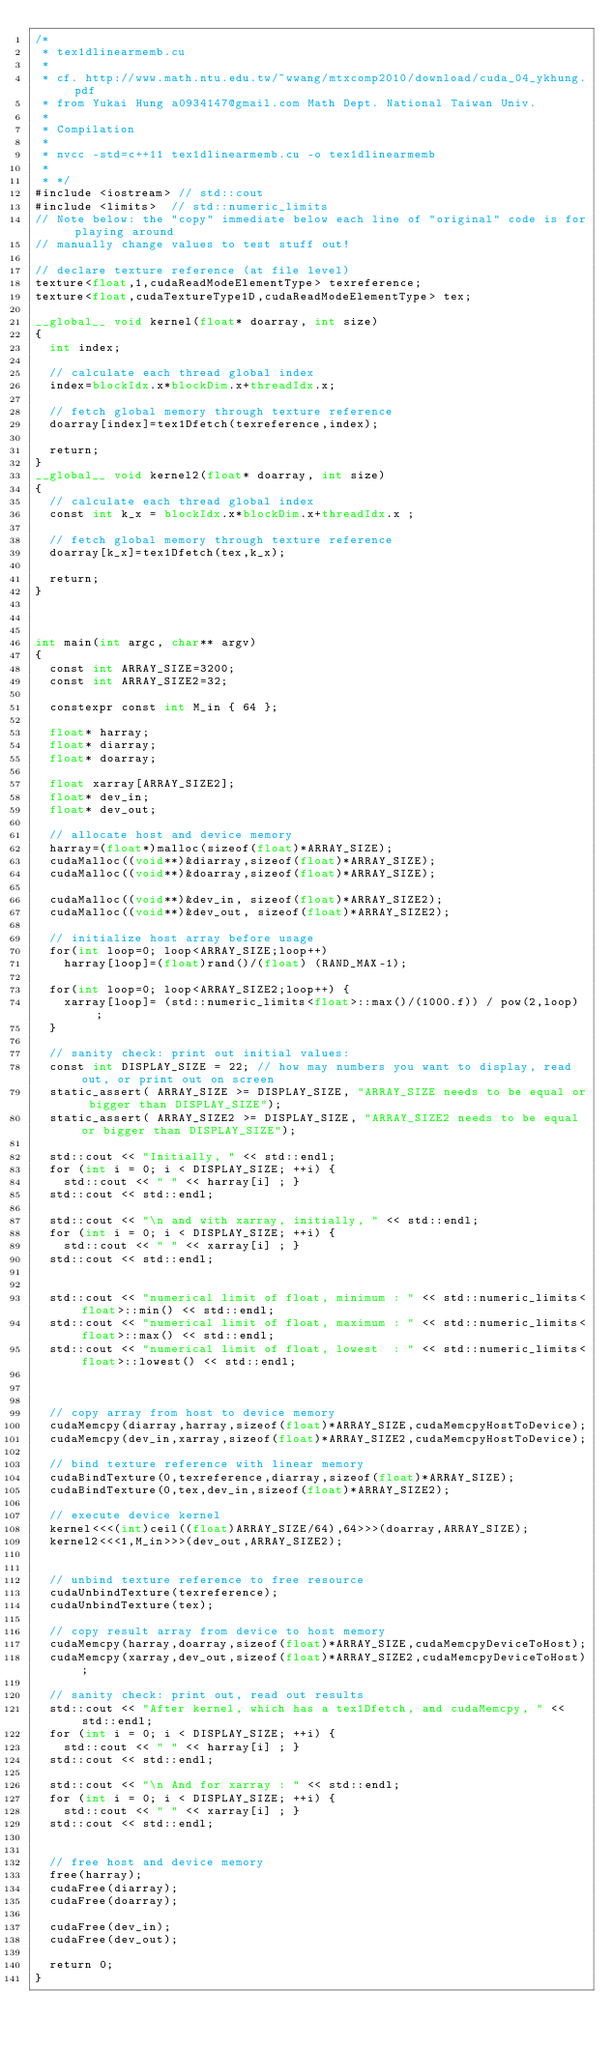<code> <loc_0><loc_0><loc_500><loc_500><_Cuda_>/*
 * tex1dlinearmemb.cu
 * 
 * cf. http://www.math.ntu.edu.tw/~wwang/mtxcomp2010/download/cuda_04_ykhung.pdf
 * from Yukai Hung a0934147@gmail.com Math Dept. National Taiwan Univ.
 * 
 * Compilation
 * 
 * nvcc -std=c++11 tex1dlinearmemb.cu -o tex1dlinearmemb
 * 
 * */
#include <iostream> // std::cout
#include <limits>  // std::numeric_limits
// Note below: the "copy" immediate below each line of "original" code is for playing around
// manually change values to test stuff out!

// declare texture reference (at file level)
texture<float,1,cudaReadModeElementType> texreference;
texture<float,cudaTextureType1D,cudaReadModeElementType> tex;

__global__ void kernel(float* doarray, int size)
{
	int index;
	
	// calculate each thread global index
	index=blockIdx.x*blockDim.x+threadIdx.x;
	
	// fetch global memory through texture reference
	doarray[index]=tex1Dfetch(texreference,index);
	
	return;
}
__global__ void kernel2(float* doarray, int size)
{
	// calculate each thread global index
	const int k_x = blockIdx.x*blockDim.x+threadIdx.x ;
	
	// fetch global memory through texture reference
	doarray[k_x]=tex1Dfetch(tex,k_x);
	
	return;
}



int main(int argc, char** argv)
{
	const int ARRAY_SIZE=3200;
	const int ARRAY_SIZE2=32; 

	constexpr const int M_in { 64 };
	
	float* harray;
	float* diarray;
	float* doarray;
	
	float xarray[ARRAY_SIZE2];
	float* dev_in;
	float* dev_out;
	
	// allocate host and device memory
	harray=(float*)malloc(sizeof(float)*ARRAY_SIZE);
	cudaMalloc((void**)&diarray,sizeof(float)*ARRAY_SIZE);
	cudaMalloc((void**)&doarray,sizeof(float)*ARRAY_SIZE);

	cudaMalloc((void**)&dev_in, sizeof(float)*ARRAY_SIZE2);
	cudaMalloc((void**)&dev_out, sizeof(float)*ARRAY_SIZE2);
	
	// initialize host array before usage
	for(int loop=0; loop<ARRAY_SIZE;loop++)
		harray[loop]=(float)rand()/(float) (RAND_MAX-1);

	for(int loop=0; loop<ARRAY_SIZE2;loop++) {
		xarray[loop]= (std::numeric_limits<float>::max()/(1000.f)) / pow(2,loop) ;
	}

	// sanity check: print out initial values:
	const int DISPLAY_SIZE = 22; // how may numbers you want to display, read out, or print out on screen
	static_assert( ARRAY_SIZE >= DISPLAY_SIZE, "ARRAY_SIZE needs to be equal or bigger than DISPLAY_SIZE");
	static_assert( ARRAY_SIZE2 >= DISPLAY_SIZE, "ARRAY_SIZE2 needs to be equal or bigger than DISPLAY_SIZE");

	std::cout << "Initially, " << std::endl;
	for (int i = 0; i < DISPLAY_SIZE; ++i) {
		std::cout << " " << harray[i] ; }
	std::cout << std::endl;

	std::cout << "\n and with xarray, initially, " << std::endl;
	for (int i = 0; i < DISPLAY_SIZE; ++i) {
		std::cout << " " << xarray[i] ; }
	std::cout << std::endl;


	std::cout << "numerical limit of float, minimum : " << std::numeric_limits<float>::min() << std::endl;
	std::cout << "numerical limit of float, maximum : " << std::numeric_limits<float>::max() << std::endl;
	std::cout << "numerical limit of float, lowest  : " << std::numeric_limits<float>::lowest() << std::endl;


		
	// copy array from host to device memory
	cudaMemcpy(diarray,harray,sizeof(float)*ARRAY_SIZE,cudaMemcpyHostToDevice);
	cudaMemcpy(dev_in,xarray,sizeof(float)*ARRAY_SIZE2,cudaMemcpyHostToDevice);

	// bind texture reference with linear memory
	cudaBindTexture(0,texreference,diarray,sizeof(float)*ARRAY_SIZE);
	cudaBindTexture(0,tex,dev_in,sizeof(float)*ARRAY_SIZE2);

	// execute device kernel
	kernel<<<(int)ceil((float)ARRAY_SIZE/64),64>>>(doarray,ARRAY_SIZE);
	kernel2<<<1,M_in>>>(dev_out,ARRAY_SIZE2);
	
	
	// unbind texture reference to free resource
	cudaUnbindTexture(texreference);
	cudaUnbindTexture(tex);
	
	// copy result array from device to host memory
	cudaMemcpy(harray,doarray,sizeof(float)*ARRAY_SIZE,cudaMemcpyDeviceToHost);
	cudaMemcpy(xarray,dev_out,sizeof(float)*ARRAY_SIZE2,cudaMemcpyDeviceToHost);

	// sanity check: print out, read out results
	std::cout << "After kernel, which has a tex1Dfetch, and cudaMemcpy, " << std::endl;
	for (int i = 0; i < DISPLAY_SIZE; ++i) {
		std::cout << " " << harray[i] ; }
	std::cout << std::endl;

	std::cout << "\n And for xarray : " << std::endl;
	for (int i = 0; i < DISPLAY_SIZE; ++i) {
		std::cout << " " << xarray[i] ; }
	std::cout << std::endl;

	
	// free host and device memory
	free(harray);
	cudaFree(diarray);
	cudaFree(doarray);

	cudaFree(dev_in);
	cudaFree(dev_out);
	
	return 0;
}
</code> 